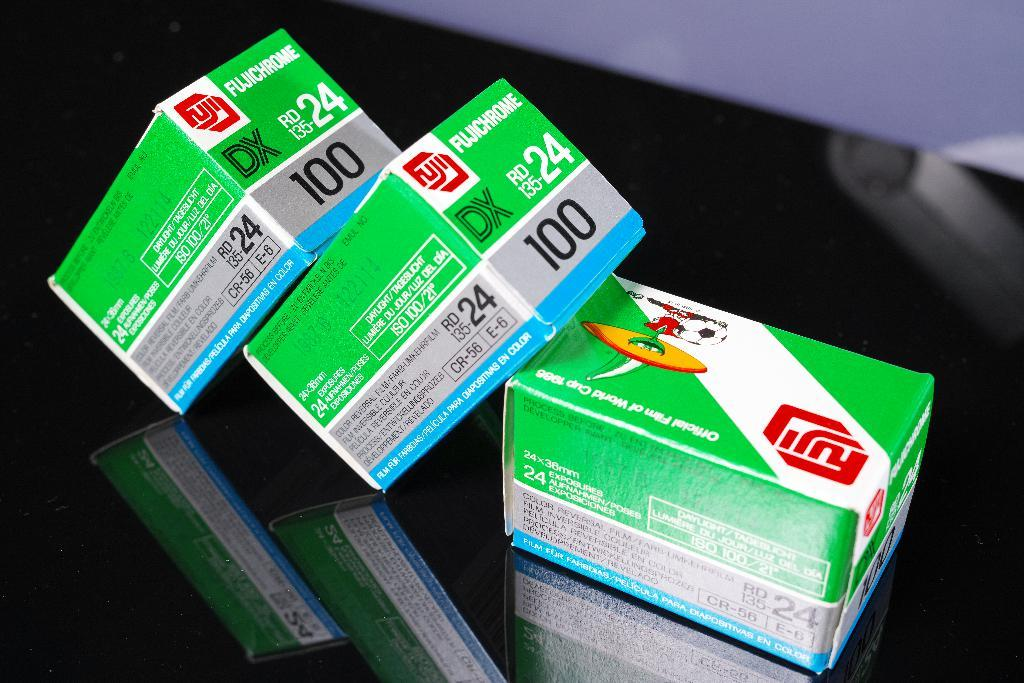Provide a one-sentence caption for the provided image. 3 boxes of Fujichrome film are on a black table. 